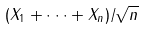<formula> <loc_0><loc_0><loc_500><loc_500>( X _ { 1 } + \cdot \cdot \cdot + X _ { n } ) / \sqrt { n }</formula> 